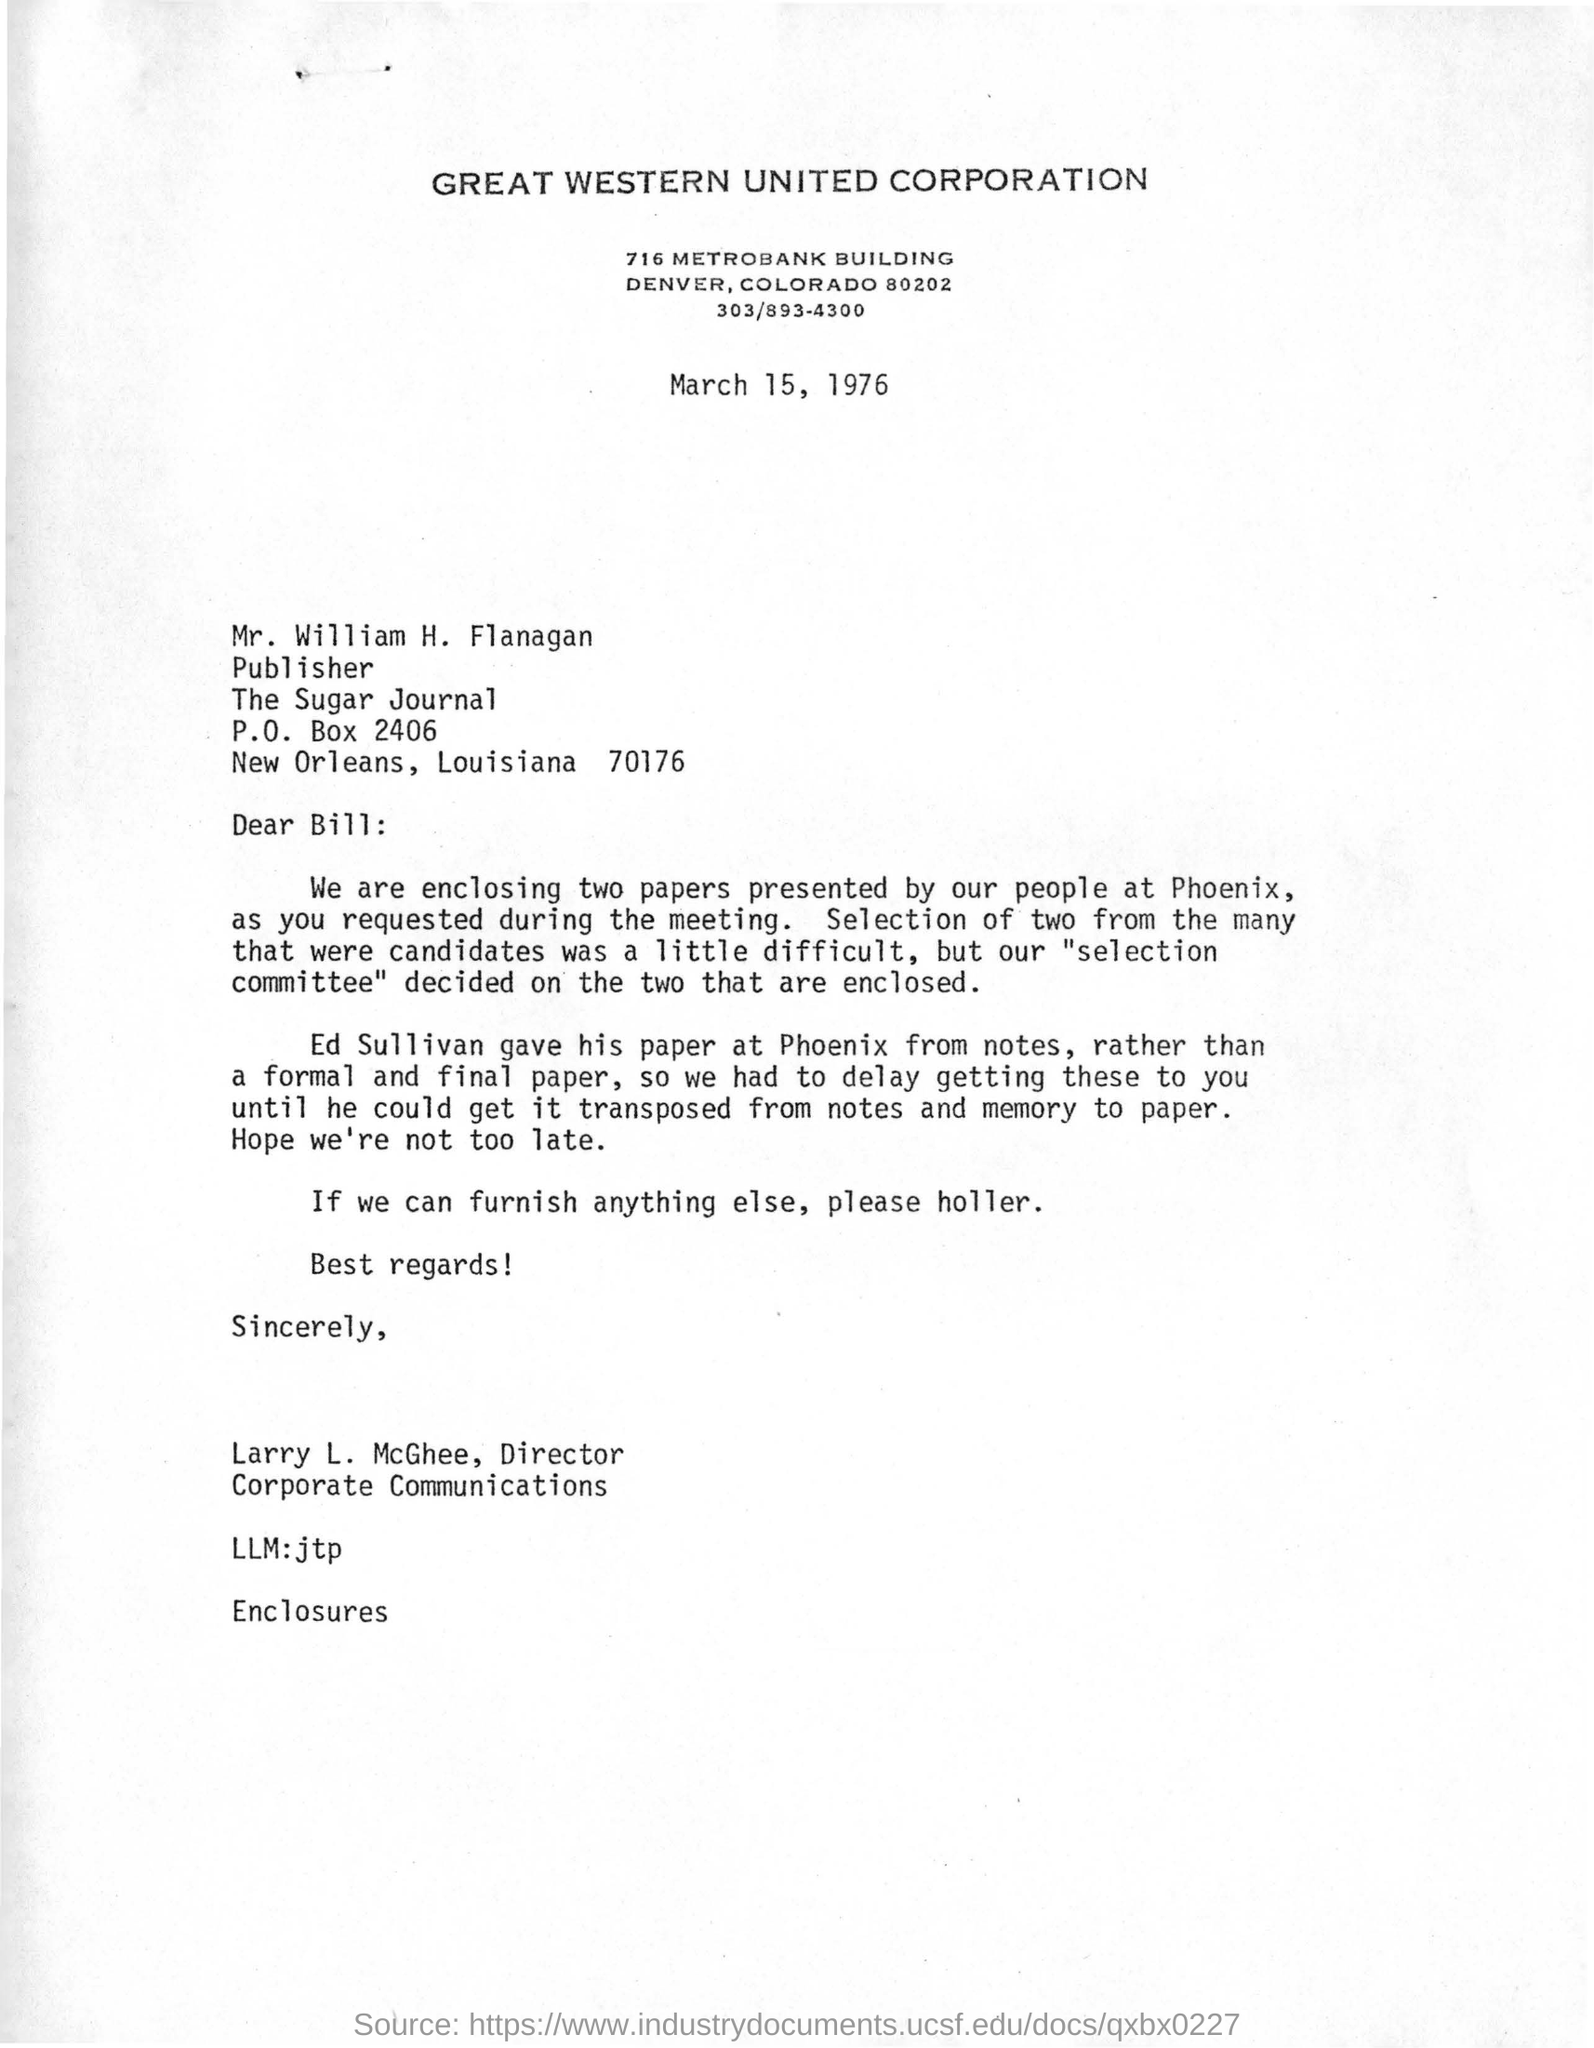Indicate a few pertinent items in this graphic. Larry L. McGhee is the director of corporate communications. The publisher of the "Sugar Journal" is Mr. William H. Flanagan. The corporation mentioned in the letter is Great Western United Corporation. The letter is dated March 15, 1976. 